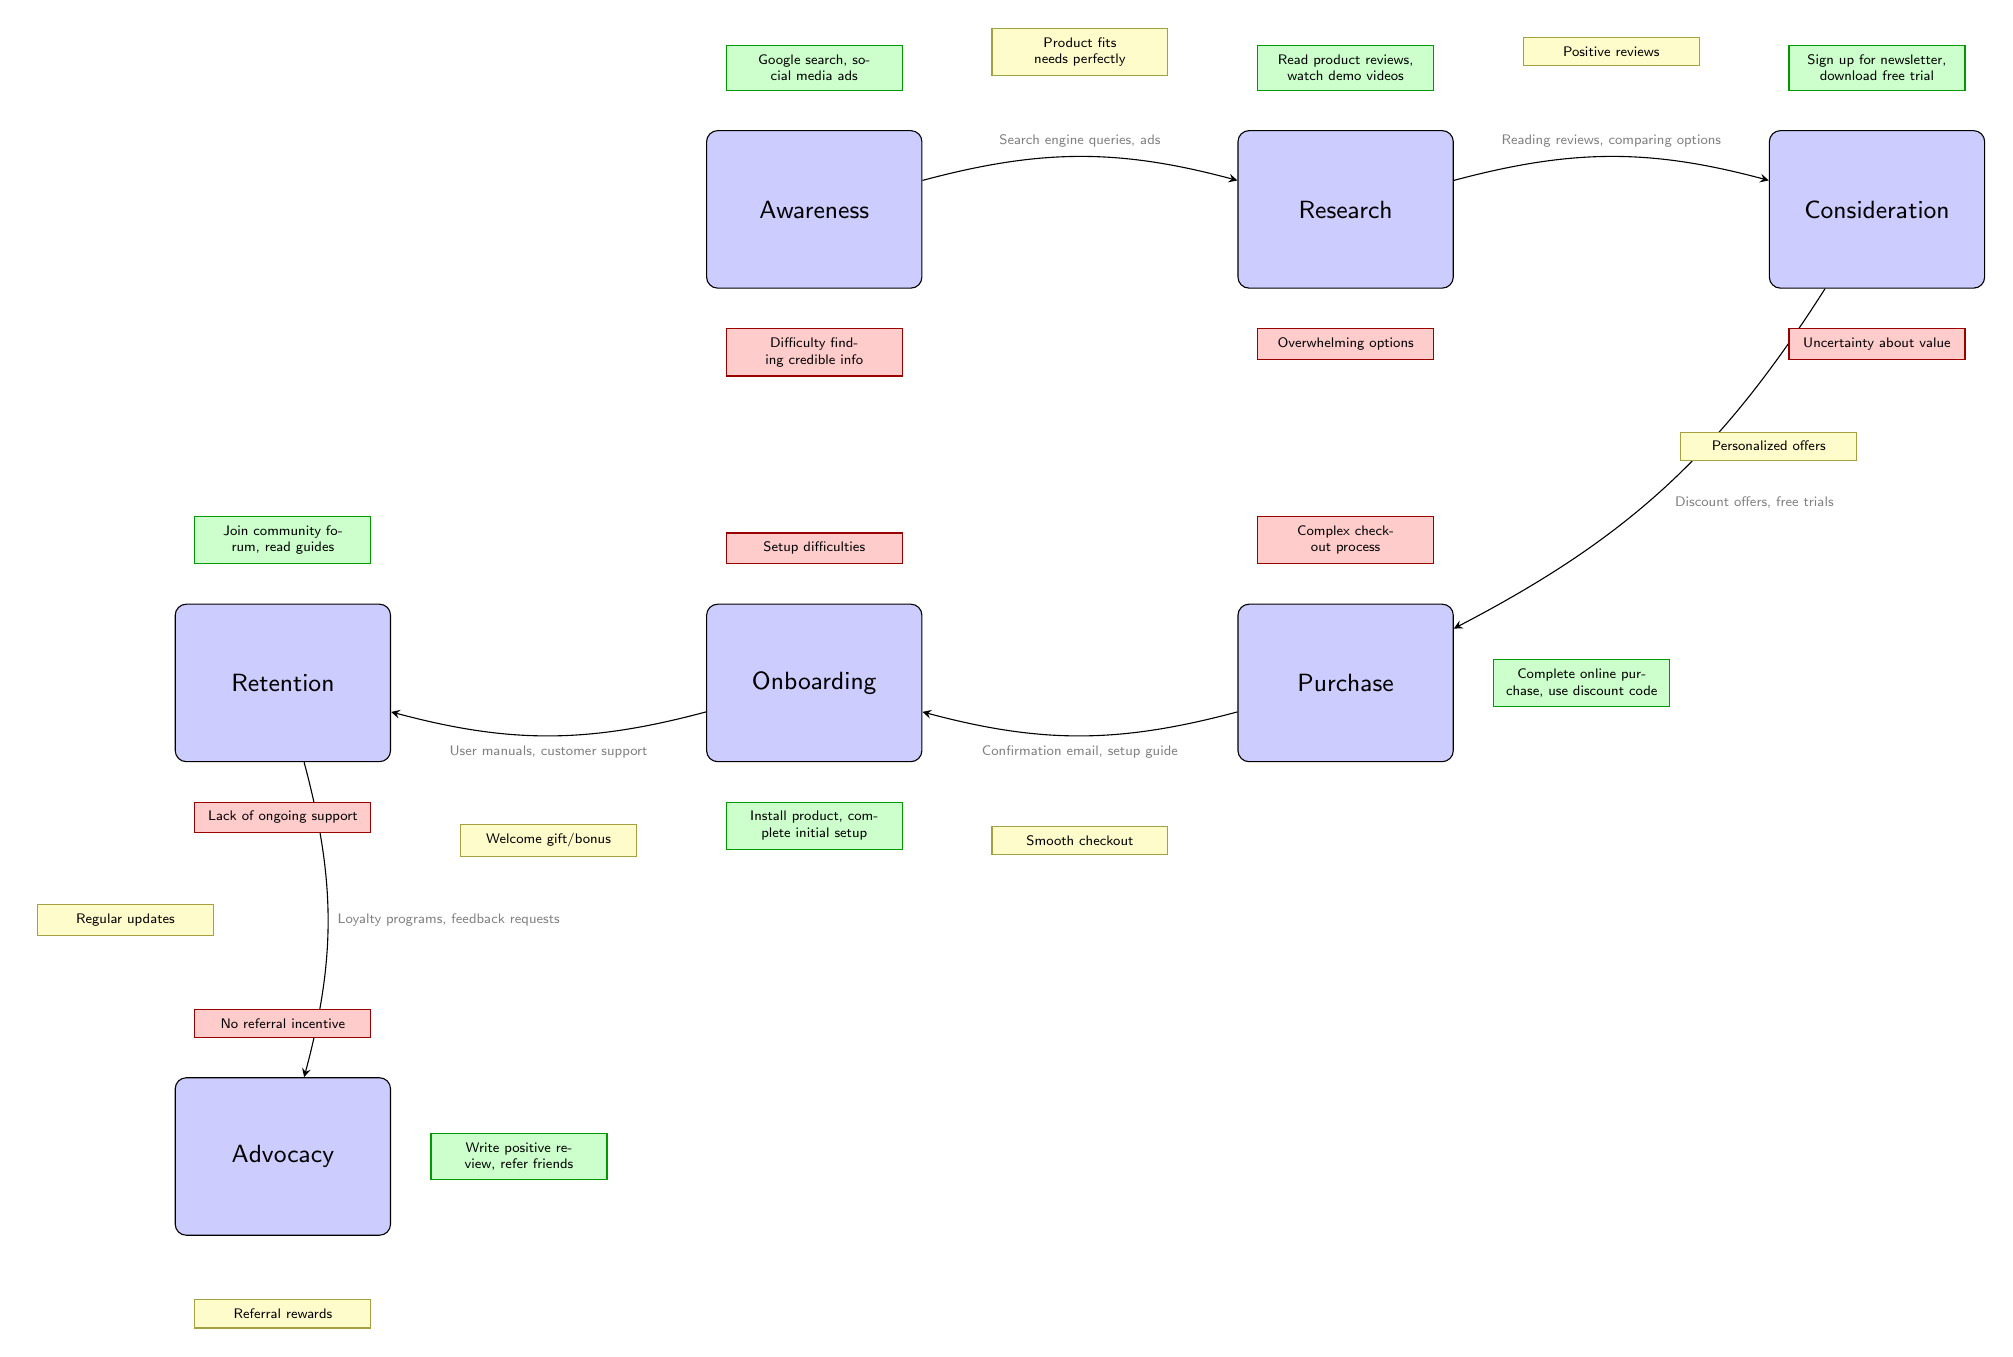What's the first stage in the customer journey? The first stage, as illustrated in the diagram, is labeled "Awareness." It is the starting point of the customer journey, highlighting when potential customers first become aware of the product.
Answer: Awareness What are the actions associated with the "Research" stage? The actions associated with the "Research" stage include reading product reviews and watching demo videos. These actions are specifically noted above the "Research" node in the diagram.
Answer: Read product reviews, watch demo videos What touchpoint connects "Purchase" to "Onboarding"? The touchpoint connecting "Purchase" to "Onboarding" includes confirmation emails and setup guides, as indicated in the diagram where arrows illustrate the flow between these two stages.
Answer: Confirmation email, setup guide How many pain points are listed in the diagram? There are a total of six pain points shown in the diagram, each corresponding to different stages of the customer journey. They can be counted by identifying the red-themed nodes throughout the diagram.
Answer: 6 What moment of delight is associated with the "Retention" stage? The moment of delight associated with the "Retention" stage is represented as "Regular updates," which is shown near the "Retention" node in the diagram.
Answer: Regular updates Which stage has two incoming edges and what are they? The stage "Retention" has two incoming edges—one from "Onboarding" and one from "Advocacy." This can be deduced by following the arrows leading to the "Retention" node and identifying the flow from previous stages.
Answer: Onboarding, Advocacy What is the relationship between "Consideration" and "Purchase"? The relationship between "Consideration" and "Purchase" is characterized by the touchpoint "Discount offers, free trials," indicating what influences the transition from considering the product to making a purchase.
Answer: Discount offers, free trials What is the last moment of delight in the journey? The last moment of delight is "Referral rewards," which is positioned subsequent to the "Advocacy" stage in the diagram, marking the end of the customer journey with a rewarding experience.
Answer: Referral rewards 